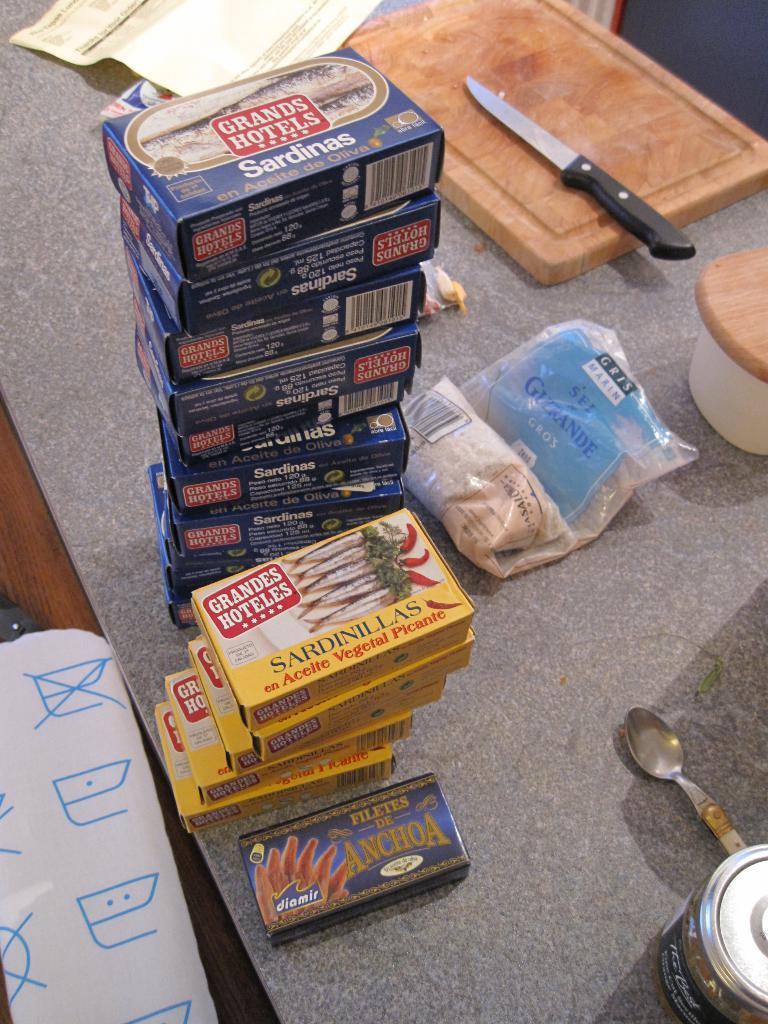What objects are on the table in the image? There are boxes, a knife, spoons, bowls, a chopping board, paper, and a cover on the table in the image. What type of utensils are on the table? There are spoons and a knife on the table. What surface is used for cutting or preparing food on the table? There is a chopping board on the table for cutting or preparing food. What might be used to cover or protect the items on the table? There is a cover on the table that might be used to cover or protect the items. How does the zebra feel about the disgusting mask on the table? There is no zebra or mask present in the image, so it is not possible to answer that question. 